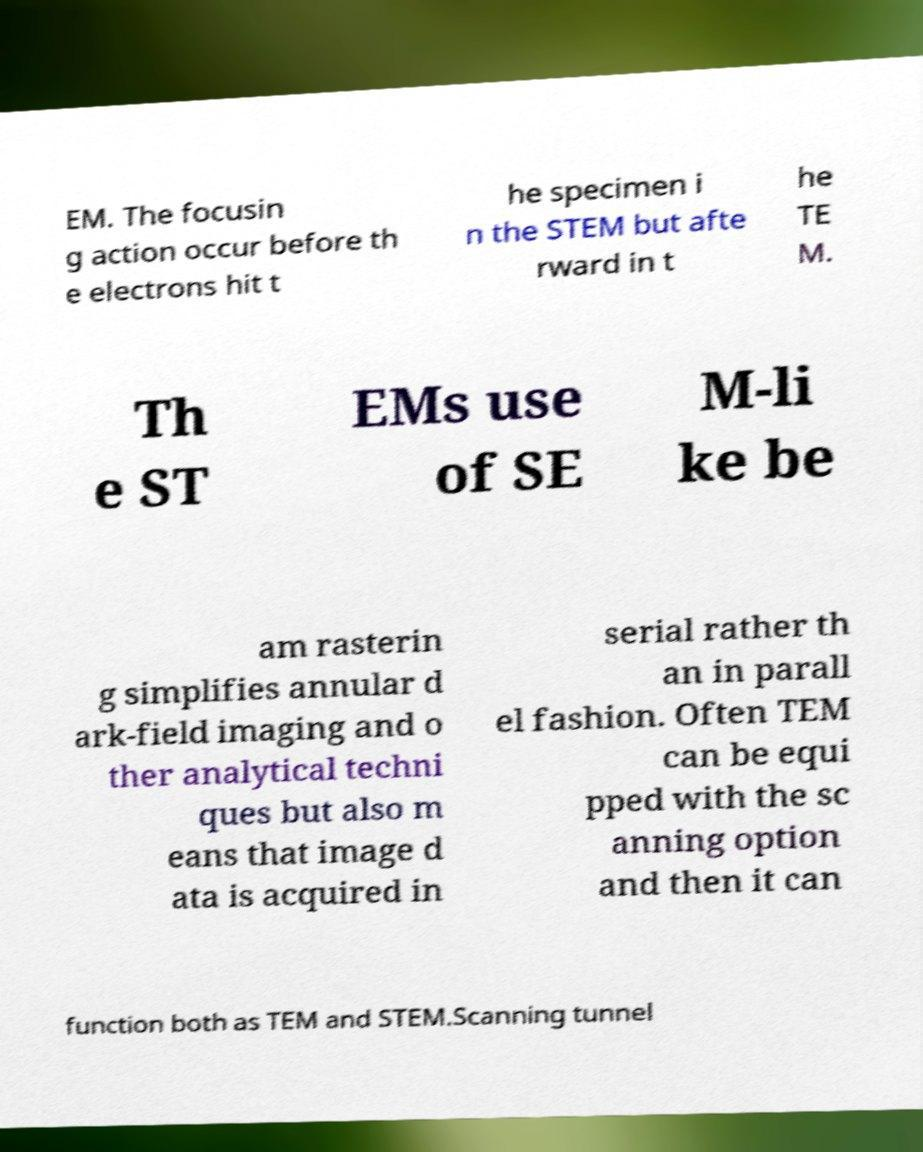What messages or text are displayed in this image? I need them in a readable, typed format. EM. The focusin g action occur before th e electrons hit t he specimen i n the STEM but afte rward in t he TE M. Th e ST EMs use of SE M-li ke be am rasterin g simplifies annular d ark-field imaging and o ther analytical techni ques but also m eans that image d ata is acquired in serial rather th an in parall el fashion. Often TEM can be equi pped with the sc anning option and then it can function both as TEM and STEM.Scanning tunnel 